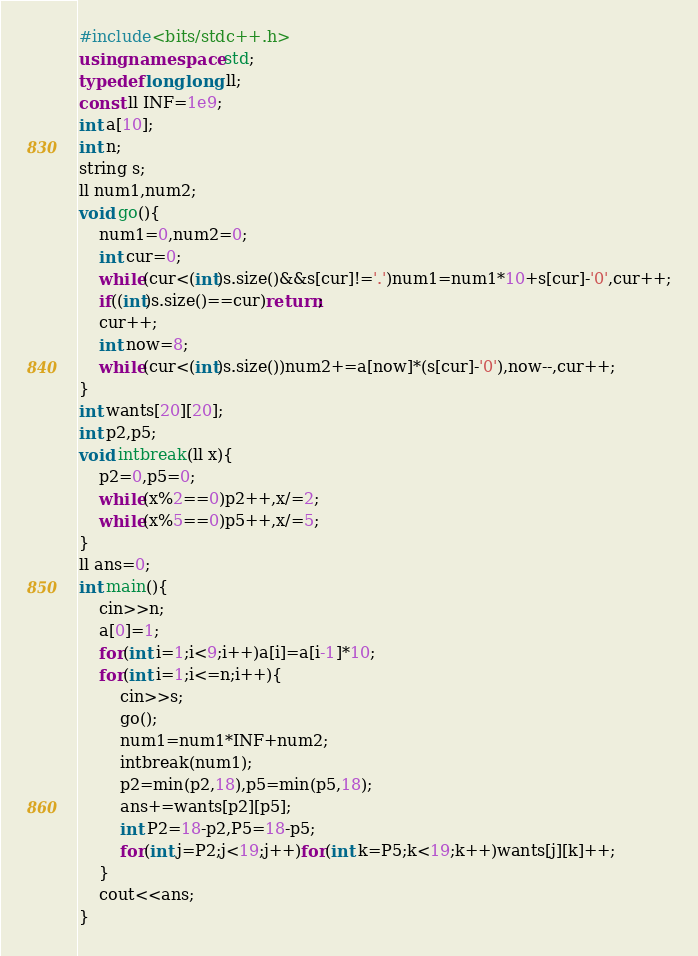<code> <loc_0><loc_0><loc_500><loc_500><_C++_>#include<bits/stdc++.h>
using namespace std;
typedef long long ll;
const ll INF=1e9; 
int a[10];
int n;
string s;
ll num1,num2;
void go(){
	num1=0,num2=0;
	int cur=0;
	while(cur<(int)s.size()&&s[cur]!='.')num1=num1*10+s[cur]-'0',cur++;
	if((int)s.size()==cur)return;
	cur++;
	int now=8;
	while(cur<(int)s.size())num2+=a[now]*(s[cur]-'0'),now--,cur++;
}
int wants[20][20];
int p2,p5;
void intbreak(ll x){
	p2=0,p5=0;
	while(x%2==0)p2++,x/=2;
	while(x%5==0)p5++,x/=5;
}
ll ans=0;
int main(){
	cin>>n;
	a[0]=1;
	for(int i=1;i<9;i++)a[i]=a[i-1]*10;
	for(int i=1;i<=n;i++){
		cin>>s;
		go();
		num1=num1*INF+num2;
		intbreak(num1);
		p2=min(p2,18),p5=min(p5,18);
		ans+=wants[p2][p5];
		int P2=18-p2,P5=18-p5;
		for(int j=P2;j<19;j++)for(int k=P5;k<19;k++)wants[j][k]++;
	}
	cout<<ans;
}</code> 